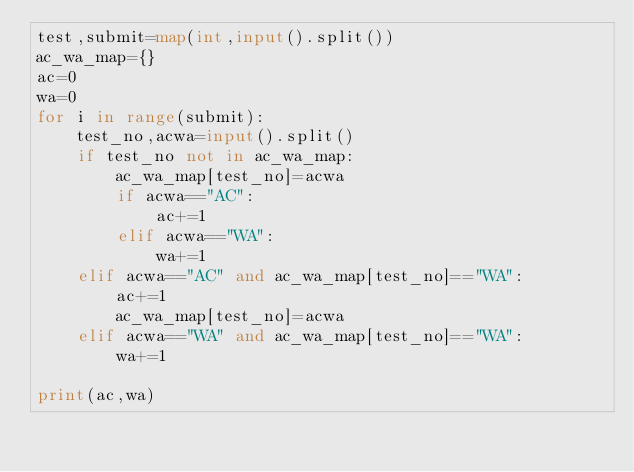Convert code to text. <code><loc_0><loc_0><loc_500><loc_500><_Python_>test,submit=map(int,input().split())
ac_wa_map={}
ac=0
wa=0
for i in range(submit):
    test_no,acwa=input().split()
    if test_no not in ac_wa_map:
        ac_wa_map[test_no]=acwa
        if acwa=="AC":
            ac+=1
        elif acwa=="WA":
            wa+=1
    elif acwa=="AC" and ac_wa_map[test_no]=="WA":
        ac+=1
        ac_wa_map[test_no]=acwa
    elif acwa=="WA" and ac_wa_map[test_no]=="WA":
        wa+=1

print(ac,wa)
        </code> 